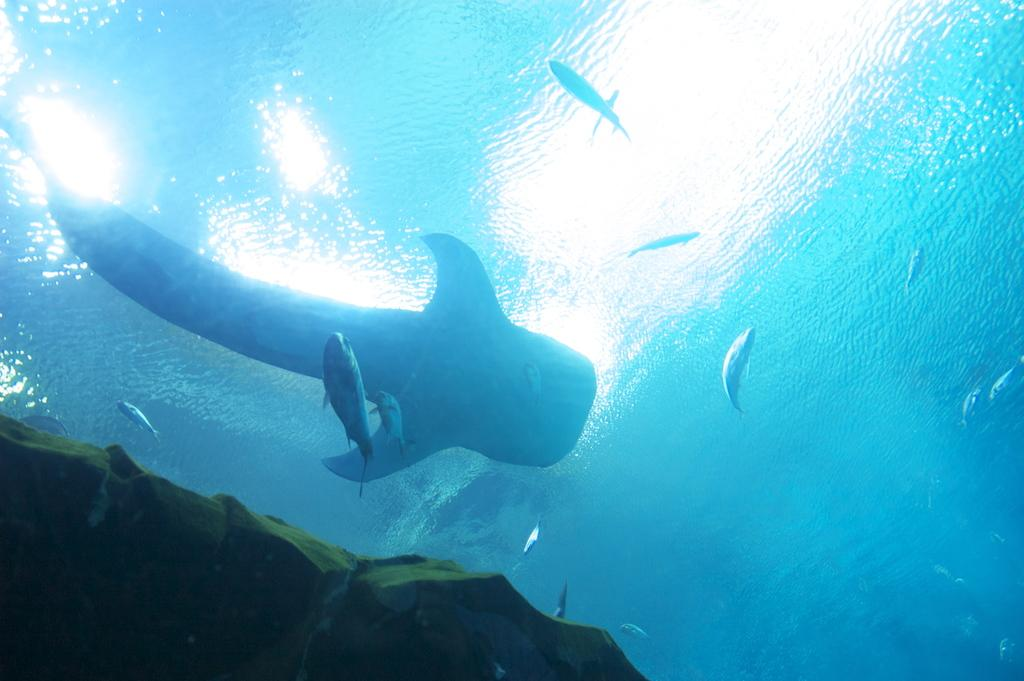What type of animals can be seen in the image? There are fishes in the image. What other objects can be seen in the image? There are rocks in the image. Where are the fishes and rocks located? The fishes and rocks are underwater. What is the opinion of the bottle in the image? There is no bottle present in the image, so it is not possible to determine its opinion. 